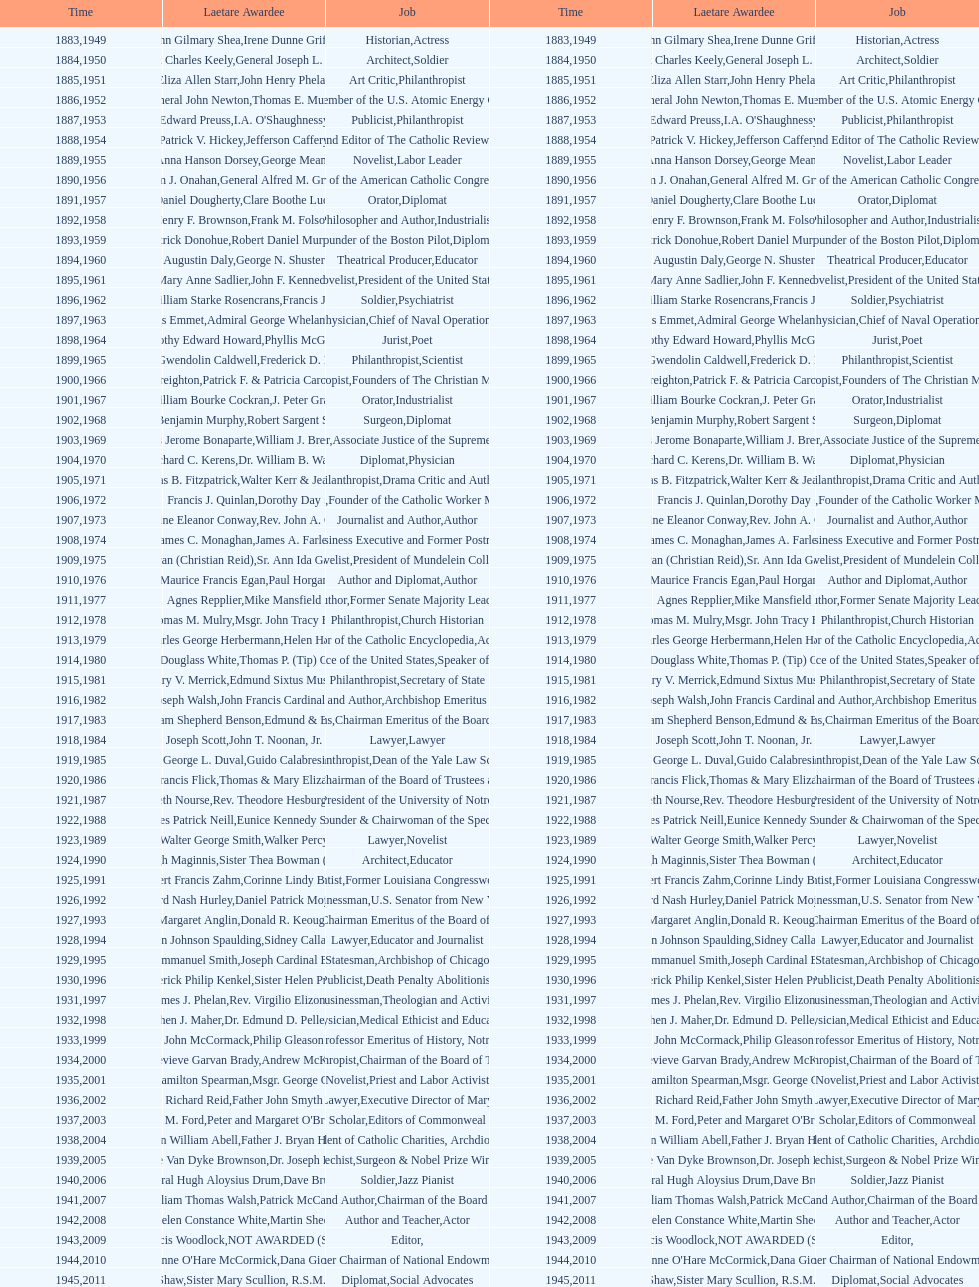What are the number of laetare medalist that held a diplomat position? 8. 